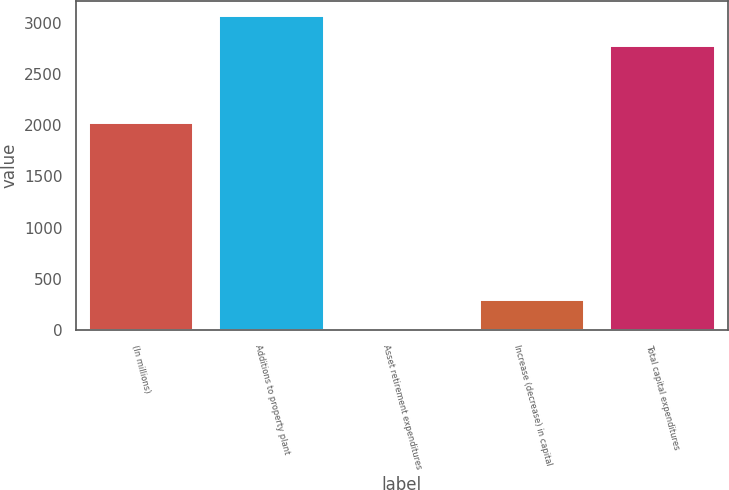Convert chart. <chart><loc_0><loc_0><loc_500><loc_500><bar_chart><fcel>(In millions)<fcel>Additions to property plant<fcel>Asset retirement expenditures<fcel>Increase (decrease) in capital<fcel>Total capital expenditures<nl><fcel>2016<fcel>3059.6<fcel>6<fcel>294.6<fcel>2771<nl></chart> 